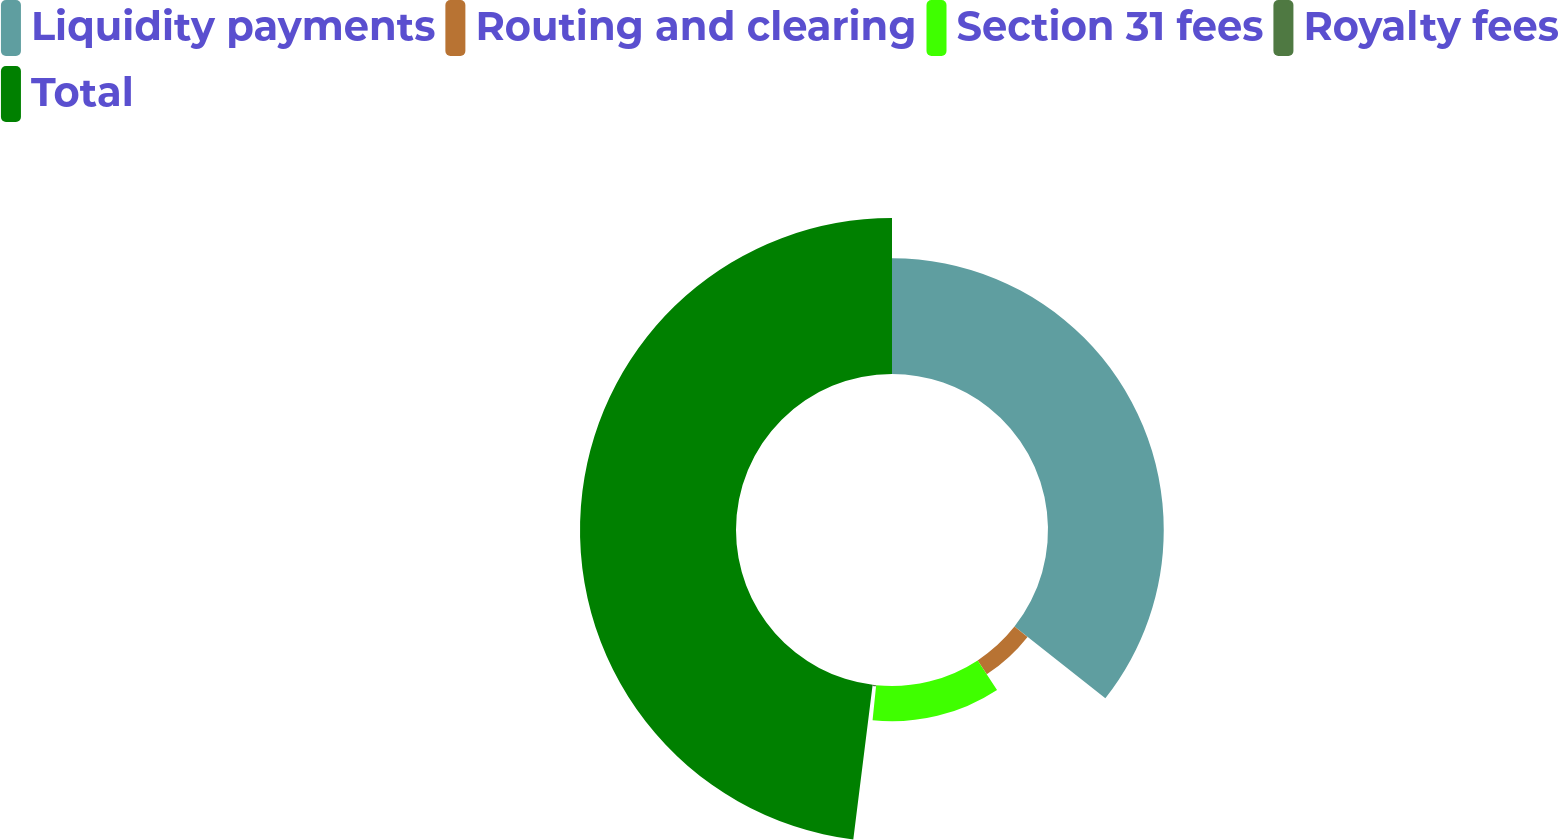Convert chart. <chart><loc_0><loc_0><loc_500><loc_500><pie_chart><fcel>Liquidity payments<fcel>Routing and clearing<fcel>Section 31 fees<fcel>Royalty fees<fcel>Total<nl><fcel>35.63%<fcel>5.12%<fcel>10.87%<fcel>0.36%<fcel>48.02%<nl></chart> 